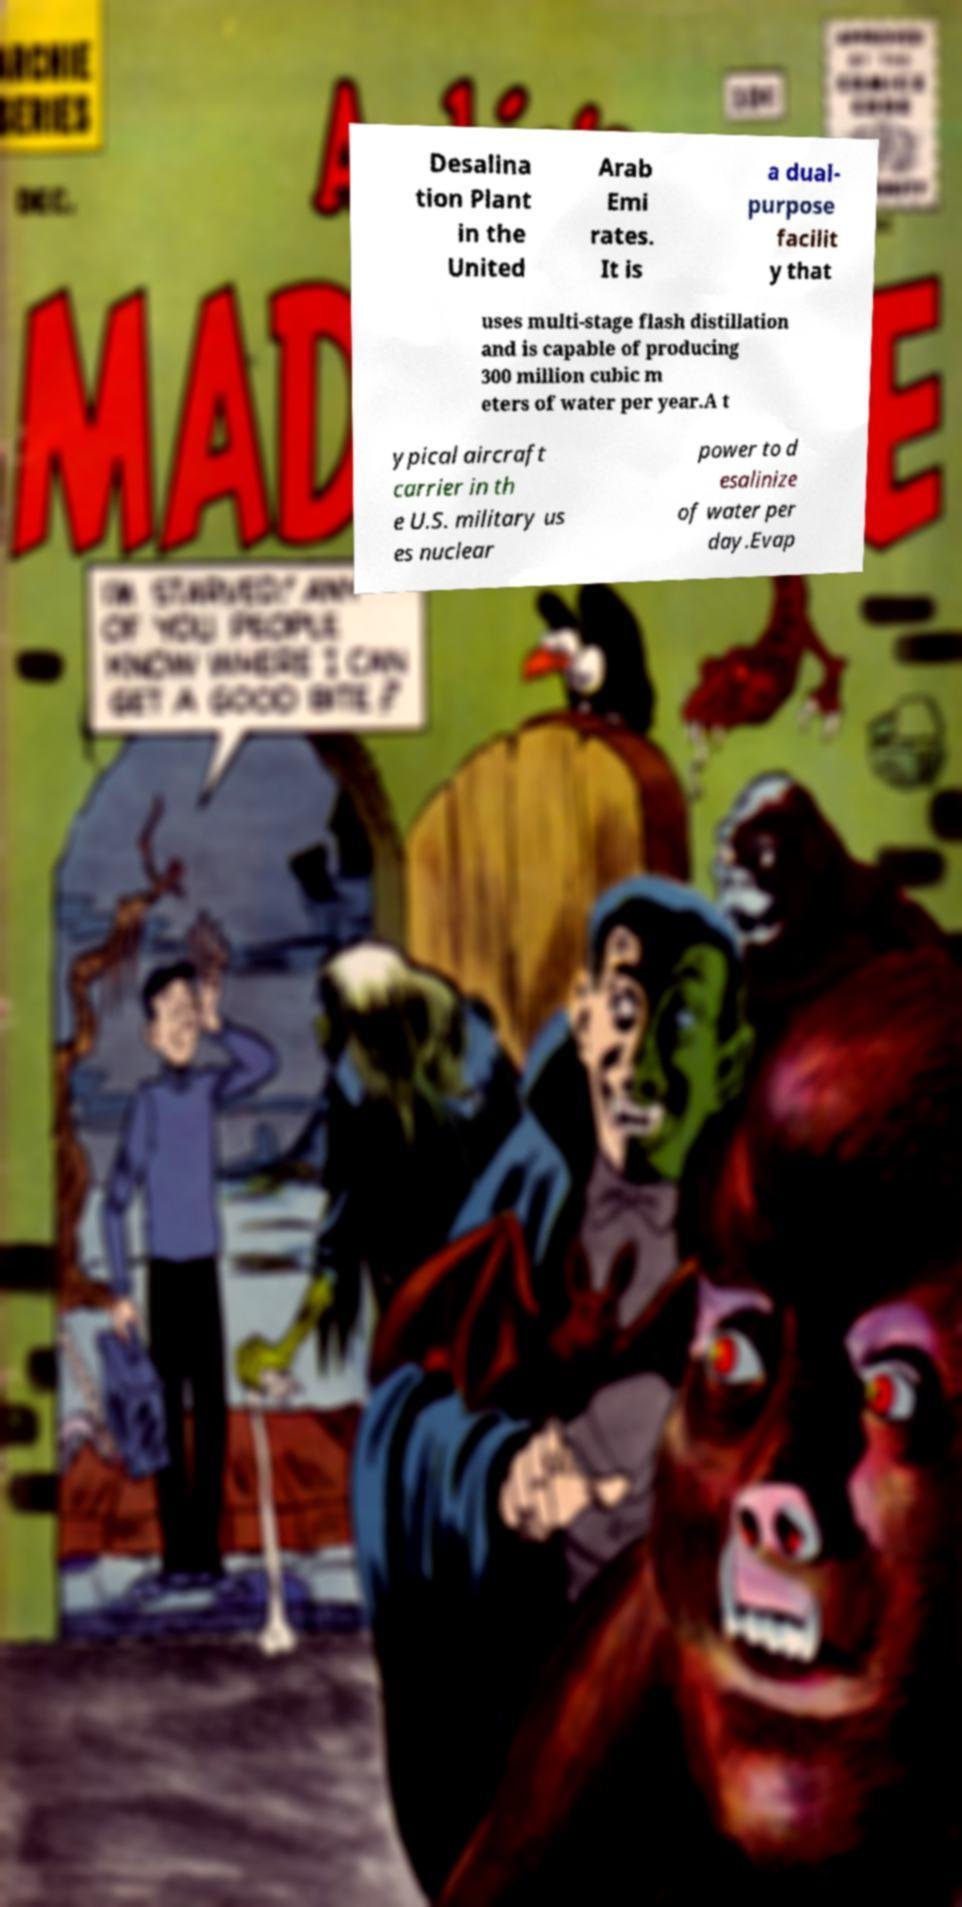Please read and relay the text visible in this image. What does it say? Desalina tion Plant in the United Arab Emi rates. It is a dual- purpose facilit y that uses multi-stage flash distillation and is capable of producing 300 million cubic m eters of water per year.A t ypical aircraft carrier in th e U.S. military us es nuclear power to d esalinize of water per day.Evap 